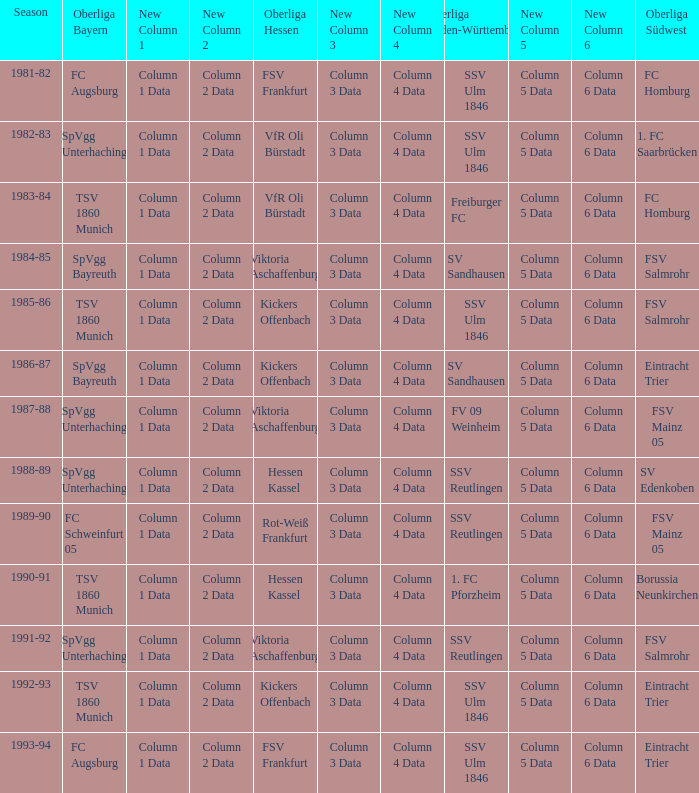Which oberliga südwes has an oberliga baden-württemberg of sv sandhausen in 1984-85? FSV Salmrohr. 